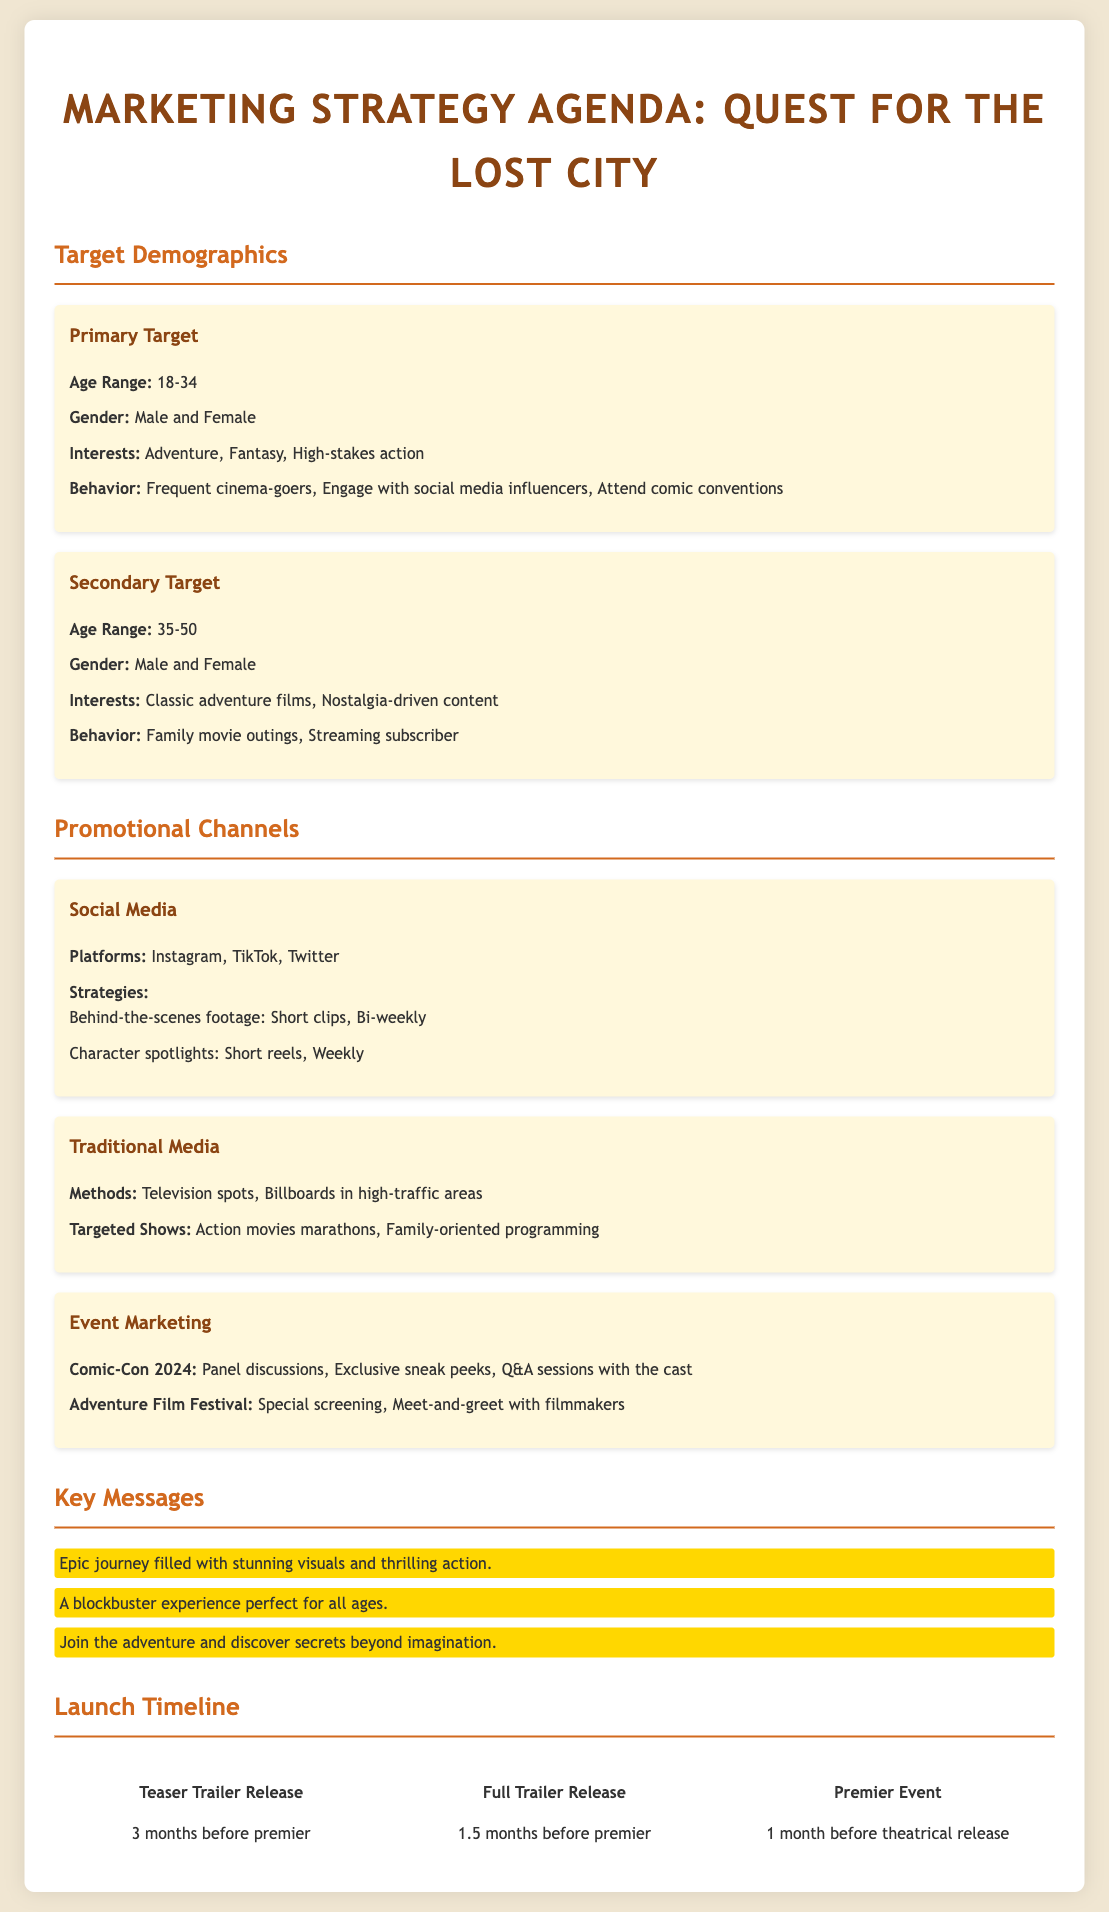What is the age range for the primary target demographic? The primary target demographic's age range is specified in the document.
Answer: 18-34 What are the interests of the secondary target demographic? The interests of the secondary target demographic are listed in the document.
Answer: Classic adventure films, Nostalgia-driven content Which platforms are included in the social media promotional channels? The platforms for social media are mentioned in the document under promotional channels.
Answer: Instagram, TikTok, Twitter What event will feature panel discussions and Q&A sessions with the cast? The specific event that includes these activities is detailed in the document.
Answer: Comic-Con 2024 How far in advance is the teaser trailer released? The timeline for the teaser trailer release is clearly stated in the document.
Answer: 3 months before premier What type of programming is targeted for traditional media advertising? The document indicates specific programming that is targeted for advertising.
Answer: Family-oriented programming What is one key message highlighted in the agenda? The document provides specific key messages that are emphasized.
Answer: Epic journey filled with stunning visuals and thrilling action When does the full trailer release occur in relation to the premiere? The timing of the full trailer release is outlined in the document.
Answer: 1.5 months before premier 